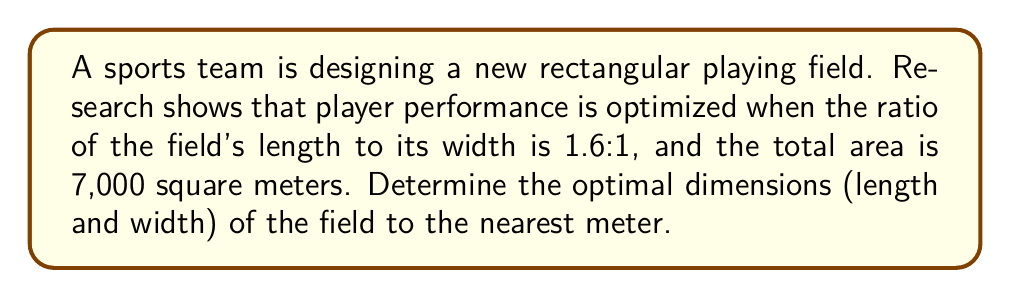What is the answer to this math problem? Let's approach this step-by-step:

1) Let $w$ be the width of the field and $l$ be the length.

2) We're given that the ratio of length to width is 1.6:1, so we can express this as:

   $$\frac{l}{w} = 1.6$$

3) We can rearrange this to express length in terms of width:

   $$l = 1.6w$$

4) We're also told that the total area is 7,000 square meters. The area of a rectangle is length times width, so:

   $$lw = 7000$$

5) Substituting our expression for $l$ from step 3:

   $$(1.6w)w = 7000$$
   $$1.6w^2 = 7000$$

6) Solving for $w$:

   $$w^2 = \frac{7000}{1.6} = 4375$$
   $$w = \sqrt{4375} \approx 66.14$$

7) Rounding to the nearest meter, $w = 66$ meters.

8) To find the length, we use our ratio from step 3:

   $$l = 1.6 * 66 = 105.6$$

9) Rounding to the nearest meter, $l = 106$ meters.

10) Let's verify: $66 * 106 = 6,996$ square meters, which is very close to our target of 7,000 square meters.
Answer: Width: 66 m, Length: 106 m 